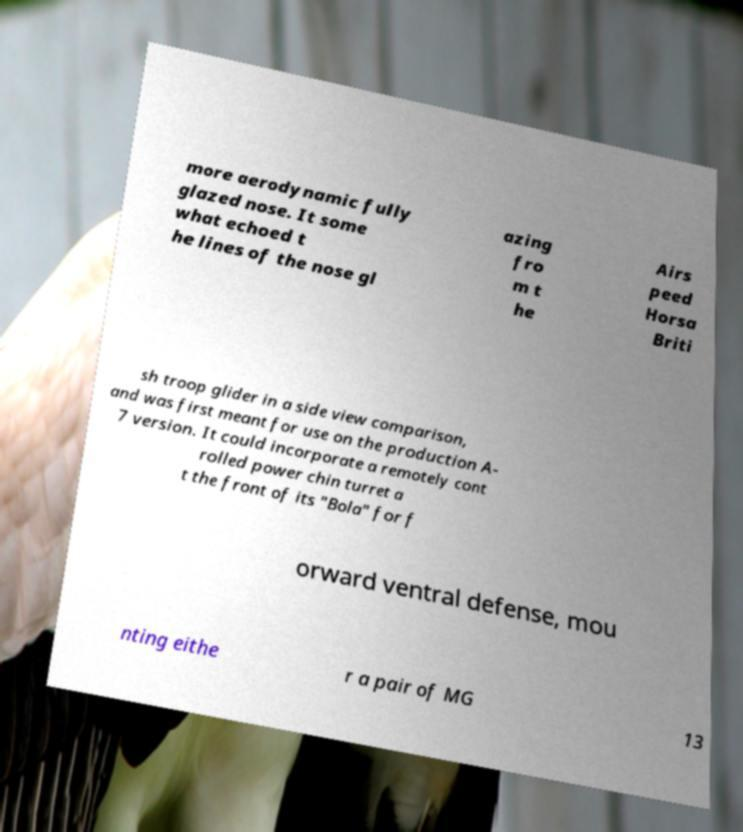Could you assist in decoding the text presented in this image and type it out clearly? more aerodynamic fully glazed nose. It some what echoed t he lines of the nose gl azing fro m t he Airs peed Horsa Briti sh troop glider in a side view comparison, and was first meant for use on the production A- 7 version. It could incorporate a remotely cont rolled power chin turret a t the front of its "Bola" for f orward ventral defense, mou nting eithe r a pair of MG 13 